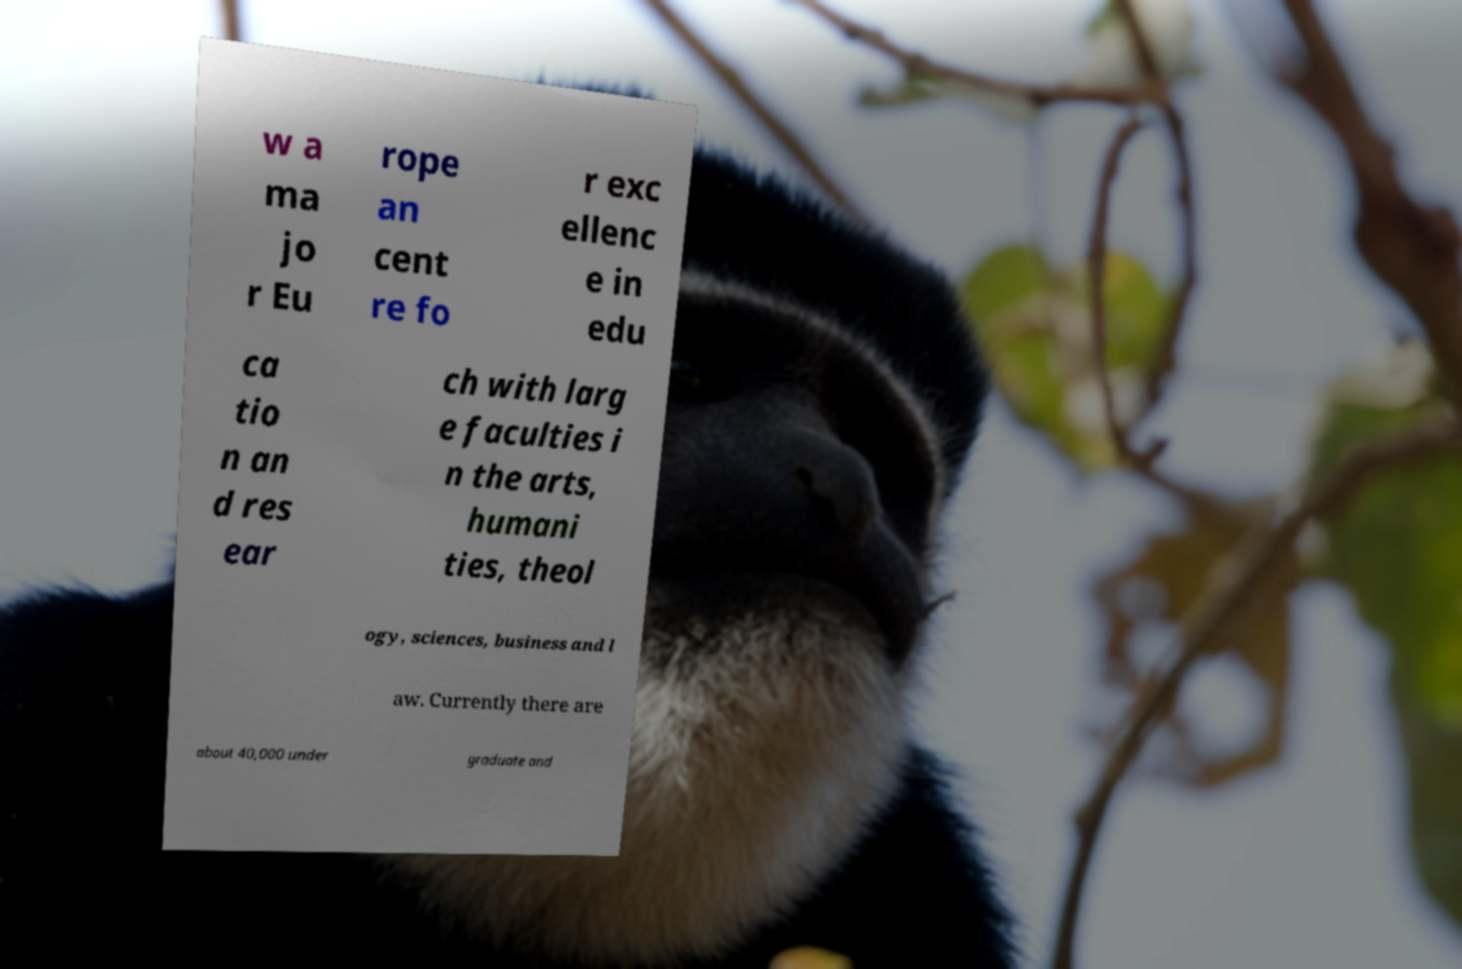Can you accurately transcribe the text from the provided image for me? w a ma jo r Eu rope an cent re fo r exc ellenc e in edu ca tio n an d res ear ch with larg e faculties i n the arts, humani ties, theol ogy, sciences, business and l aw. Currently there are about 40,000 under graduate and 